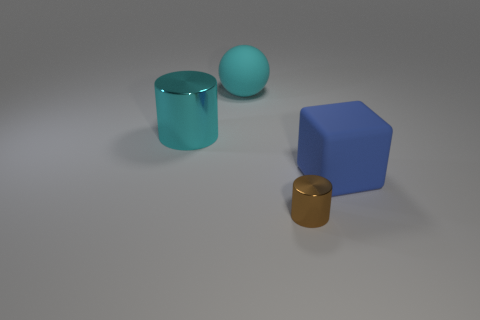Is the color of the big cylinder the same as the large matte ball?
Your response must be concise. Yes. What size is the object that is both on the right side of the big shiny object and on the left side of the small brown object?
Ensure brevity in your answer.  Large. How many large cubes are the same material as the large cylinder?
Give a very brief answer. 0. There is a object that is made of the same material as the sphere; what color is it?
Offer a very short reply. Blue. Do the cylinder right of the large cyan metal cylinder and the big shiny thing have the same color?
Ensure brevity in your answer.  No. What material is the cylinder that is in front of the cyan metal thing?
Keep it short and to the point. Metal. Are there the same number of cyan matte balls on the right side of the cyan rubber ball and cyan metallic cylinders?
Offer a terse response. No. How many rubber balls are the same color as the large shiny cylinder?
Offer a very short reply. 1. There is another object that is the same shape as the cyan shiny thing; what is its color?
Provide a succinct answer. Brown. Do the matte cube and the brown metal thing have the same size?
Give a very brief answer. No. 